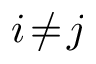Convert formula to latex. <formula><loc_0><loc_0><loc_500><loc_500>i \, \neq \, j</formula> 